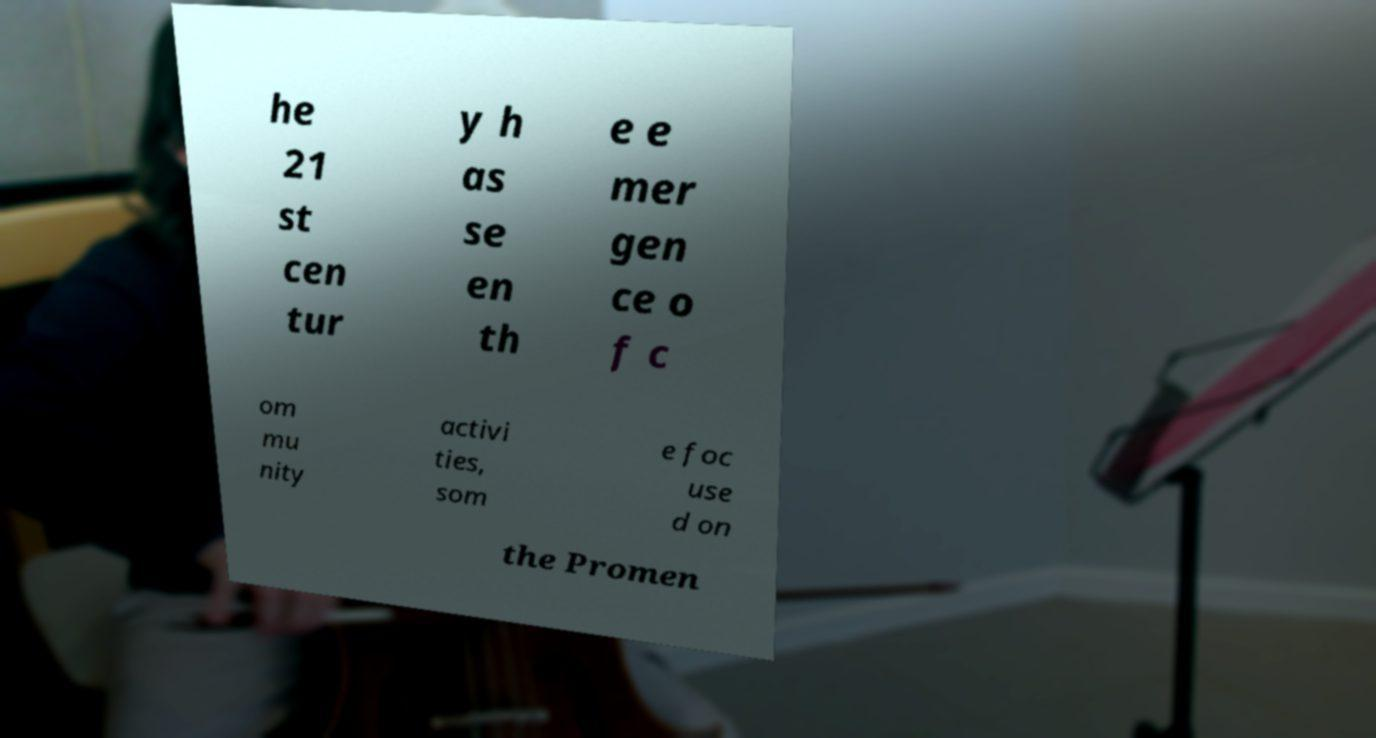Can you accurately transcribe the text from the provided image for me? he 21 st cen tur y h as se en th e e mer gen ce o f c om mu nity activi ties, som e foc use d on the Promen 